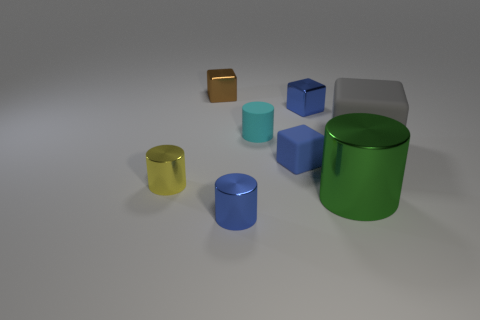Subtract 1 cylinders. How many cylinders are left? 3 Add 1 small brown cylinders. How many objects exist? 9 Add 1 small brown shiny cubes. How many small brown shiny cubes are left? 2 Add 8 small red matte cylinders. How many small red matte cylinders exist? 8 Subtract 0 yellow balls. How many objects are left? 8 Subtract all brown shiny cubes. Subtract all yellow objects. How many objects are left? 6 